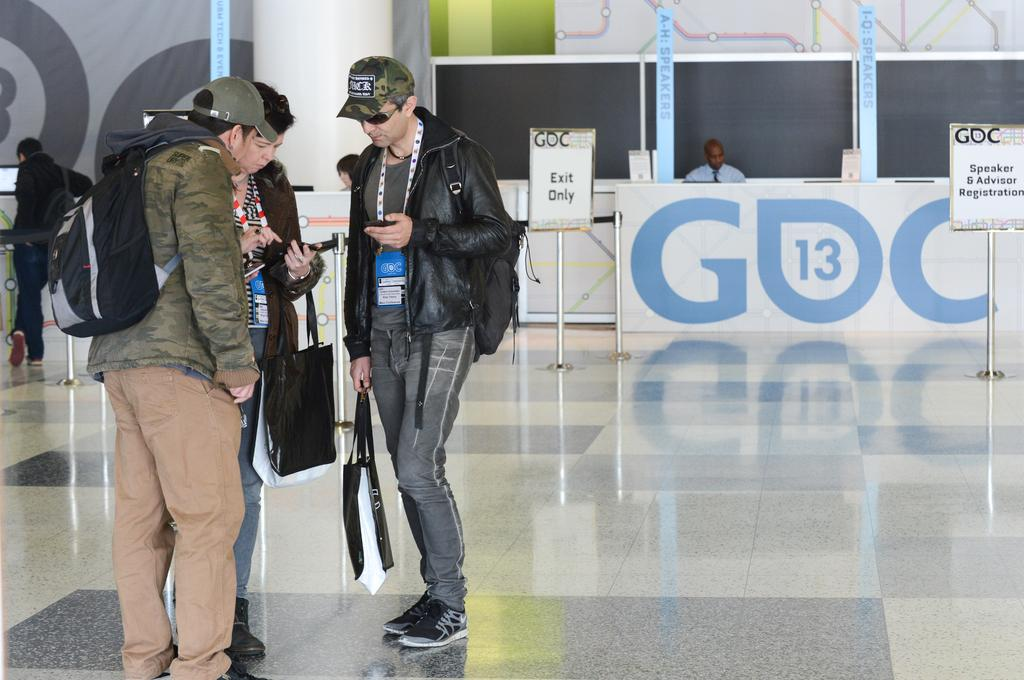What can be seen on the left side of the image? There are people on the left side of the image. What are the people wearing on their heads? The people are wearing caps. What are the people holding in their hands? The people are holding bags. Can you describe the person in the background of the image? There is a person sitting in the background of the image. What is present in the background of the image besides the person? There are text boards in the background of the image. What flavor of bath can be seen in the image? There is no bath present in the image, and therefore no flavor can be determined. 